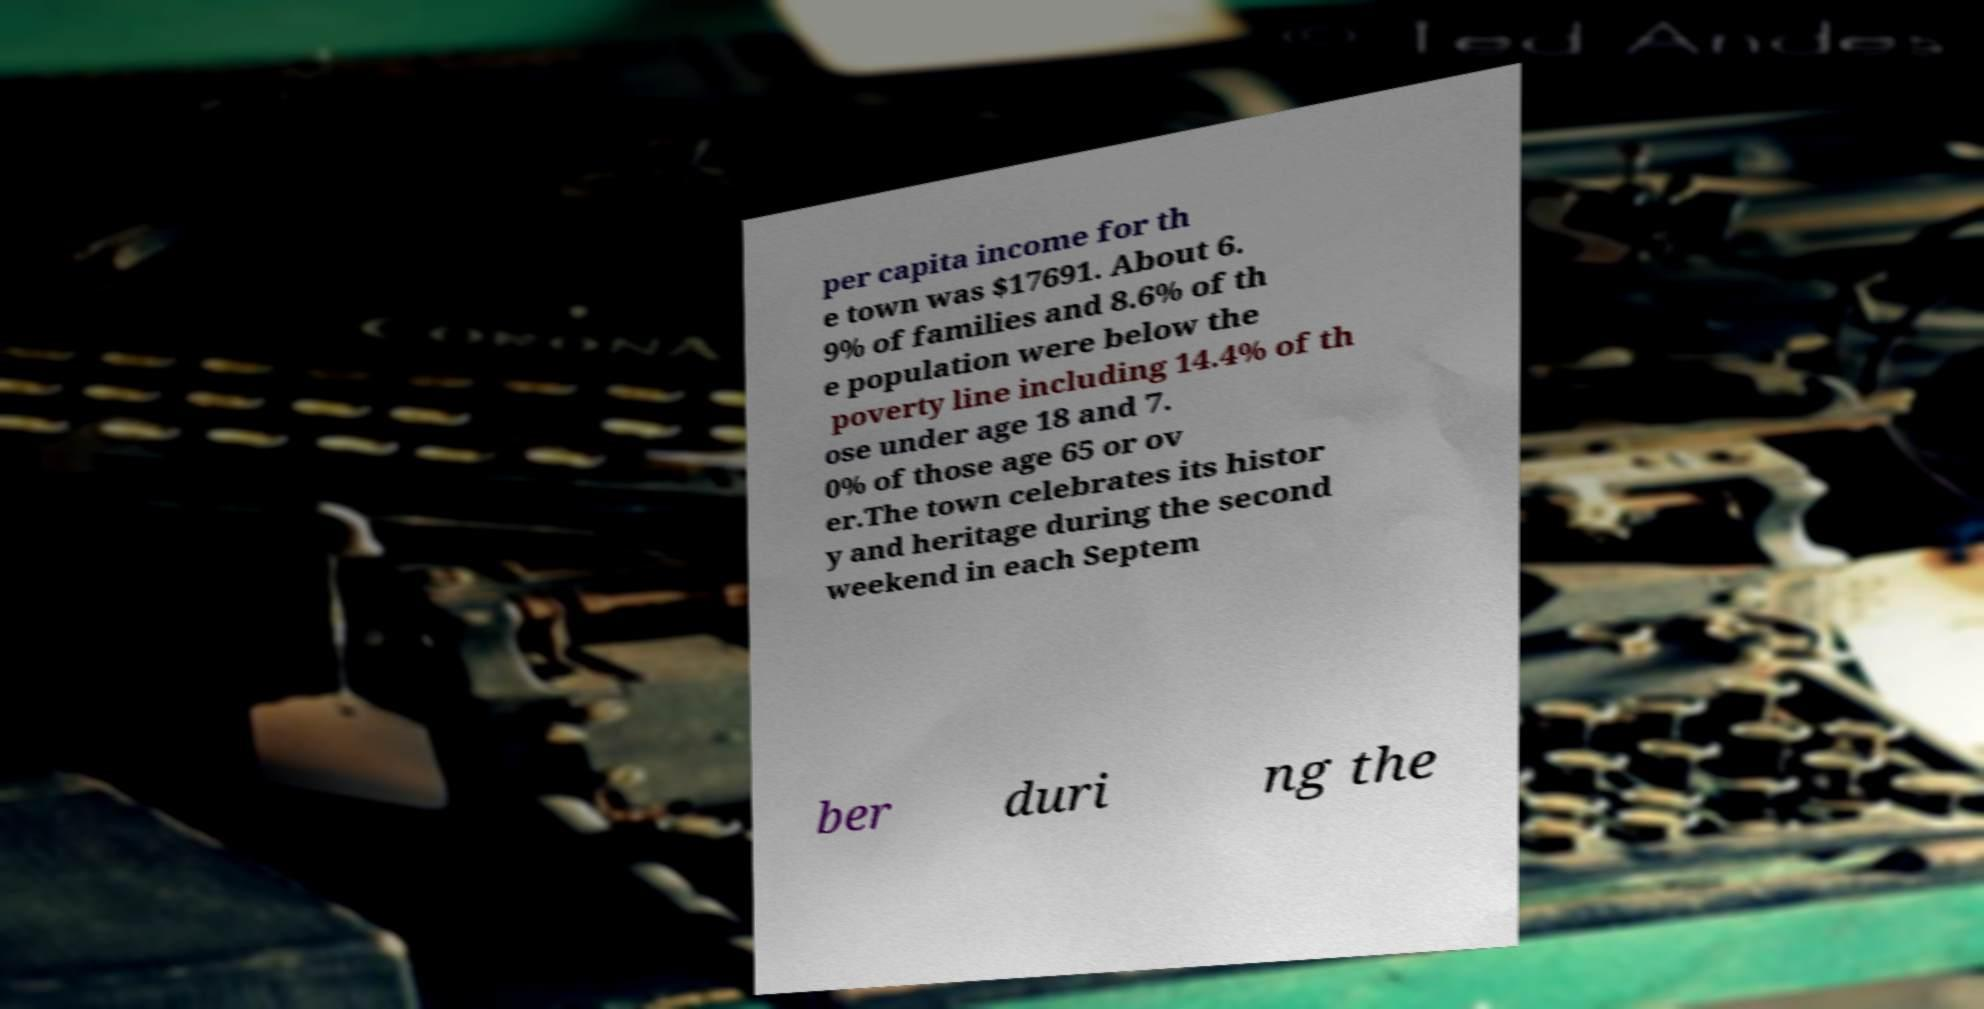Please identify and transcribe the text found in this image. per capita income for th e town was $17691. About 6. 9% of families and 8.6% of th e population were below the poverty line including 14.4% of th ose under age 18 and 7. 0% of those age 65 or ov er.The town celebrates its histor y and heritage during the second weekend in each Septem ber duri ng the 